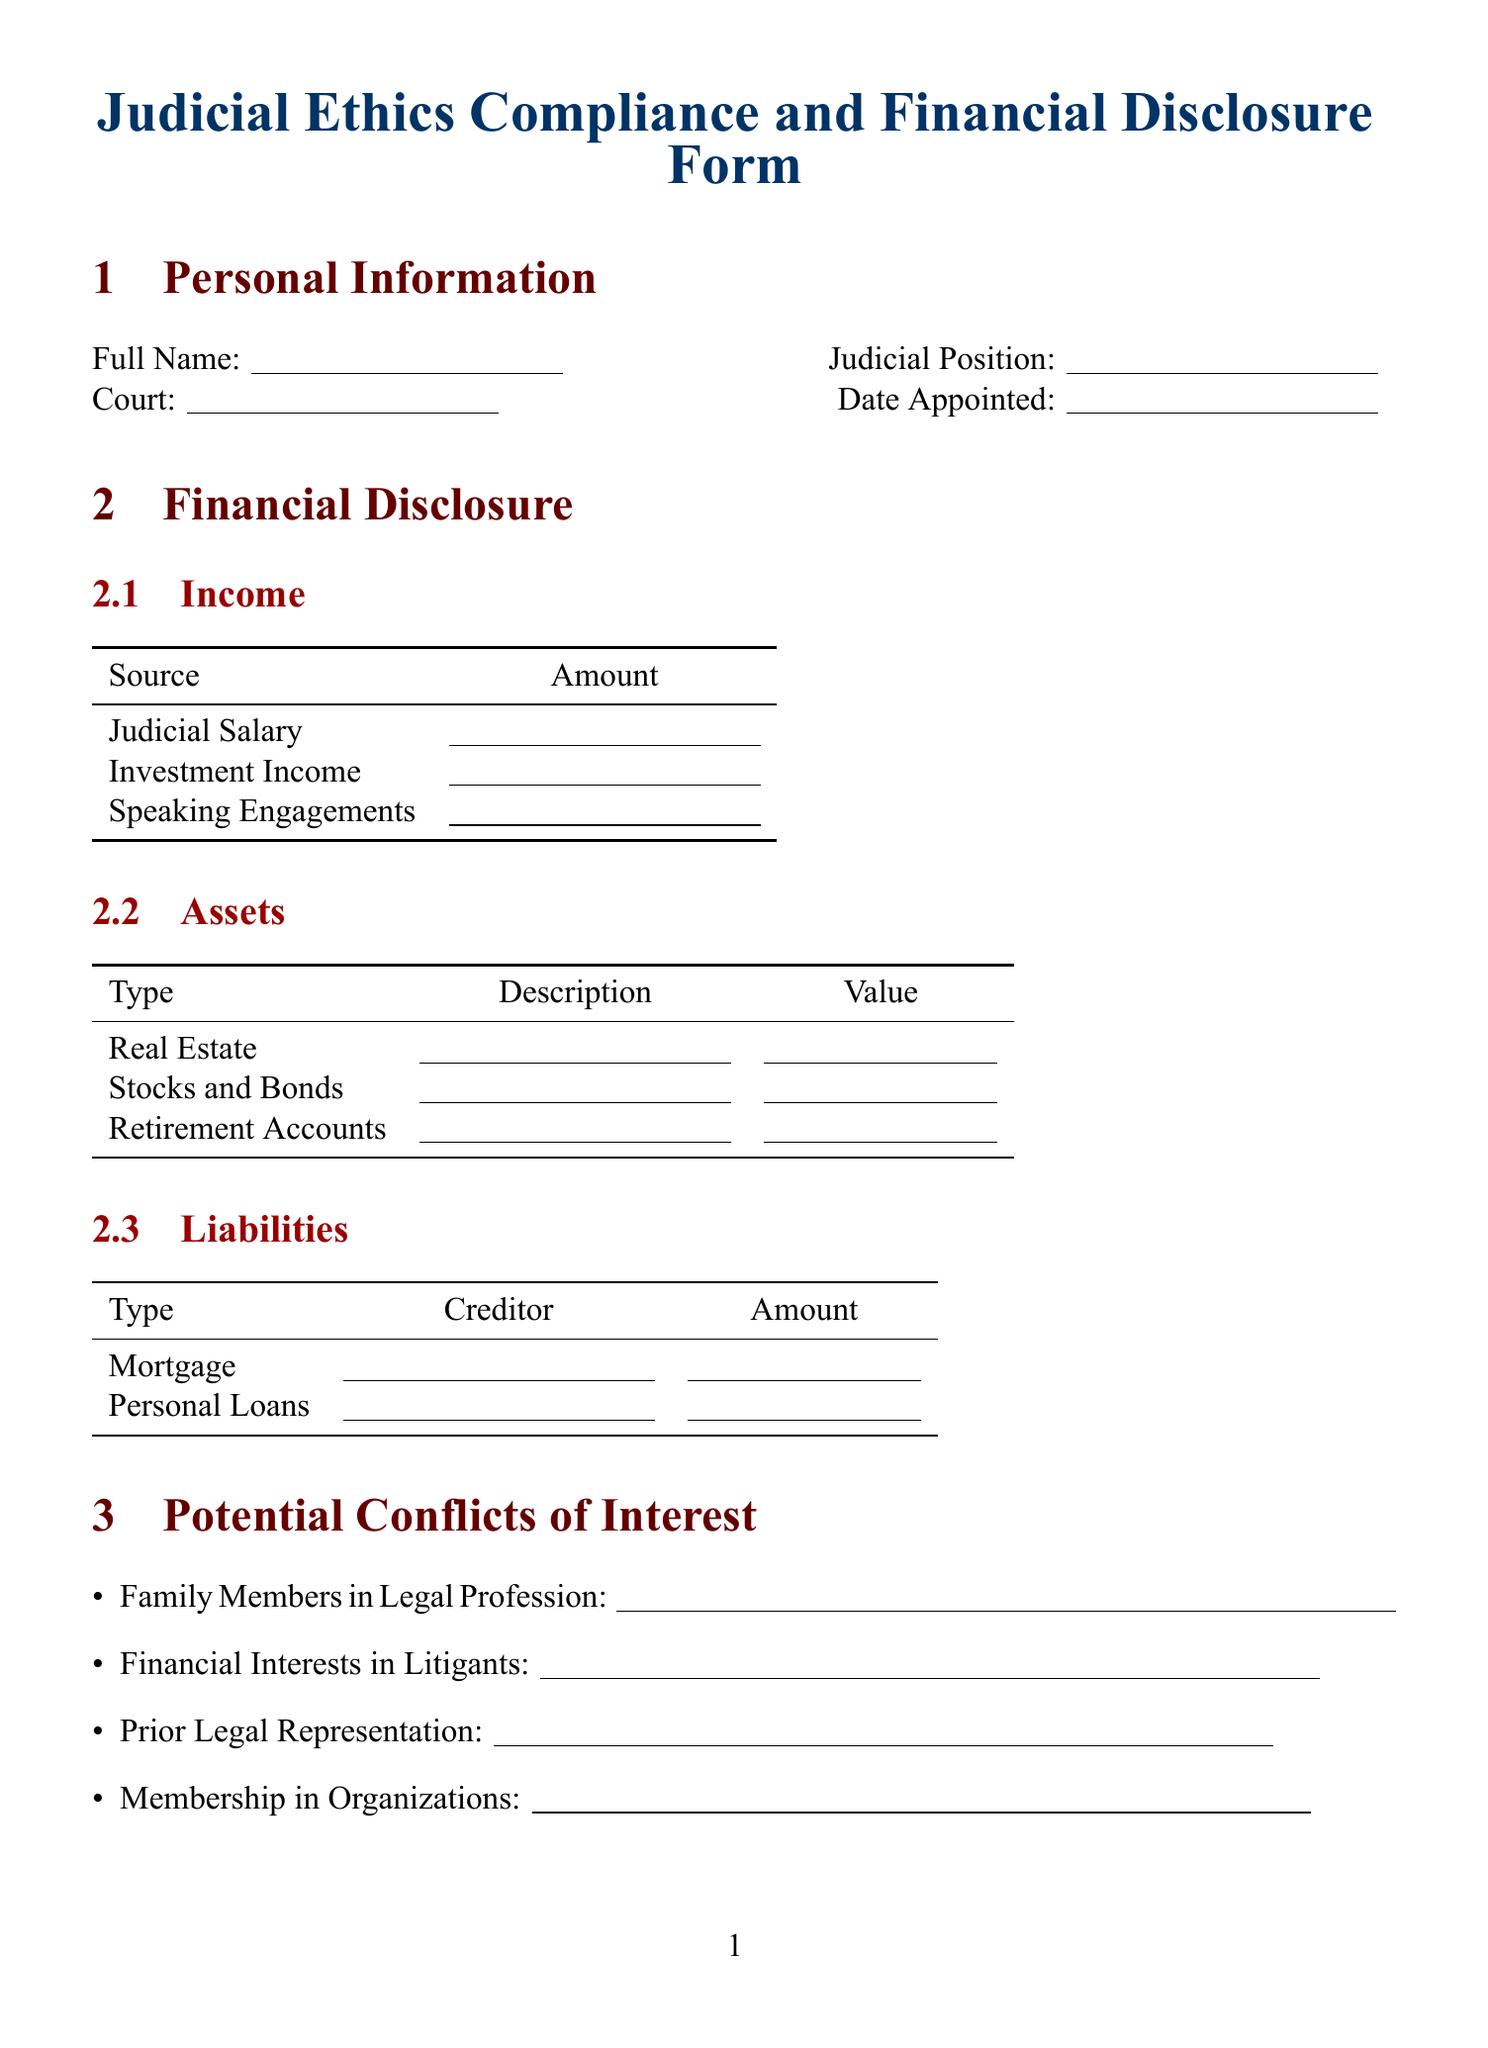What is the title of the document? The title of the document is clearly stated at the beginning of the rendered document.
Answer: Judicial Ethics Compliance and Financial Disclosure Form Who is the recipient of the form? The recipient's name is mentioned in the submission instructions section of the document.
Answer: Chief Justice John G. Roberts, Jr What is the deadline for submission? The submission instructions state a deadline for the form submission.
Answer: April 15, 2023 How many income sources are listed? The financial disclosure section lists specific income sources under income.
Answer: 3 What type of assets are included in the financial disclosure? The assets section specifies different types of assets that must be disclosed.
Answer: Real Estate, Stocks and Bonds, Retirement Accounts What are the potential conflicts of interest mentioned? The document lists specific types of potential conflicts of interest under that section.
Answer: Family Members in Legal Profession, Financial Interests in Litigants, Prior Legal Representation, Membership in Organizations Have any ethical compliance questions been included? Ethical compliance questions listed require short answers and explanations in the document.
Answer: Yes What principle relates to 'judicial restraint'? The conservative principles section identifies a specific principle regarding judicial restraint.
Answer: Judicial restraint and deference to legislative bodies Is there a certification statement included? The form contains a certification statement that must be acknowledged by the signer.
Answer: Yes 